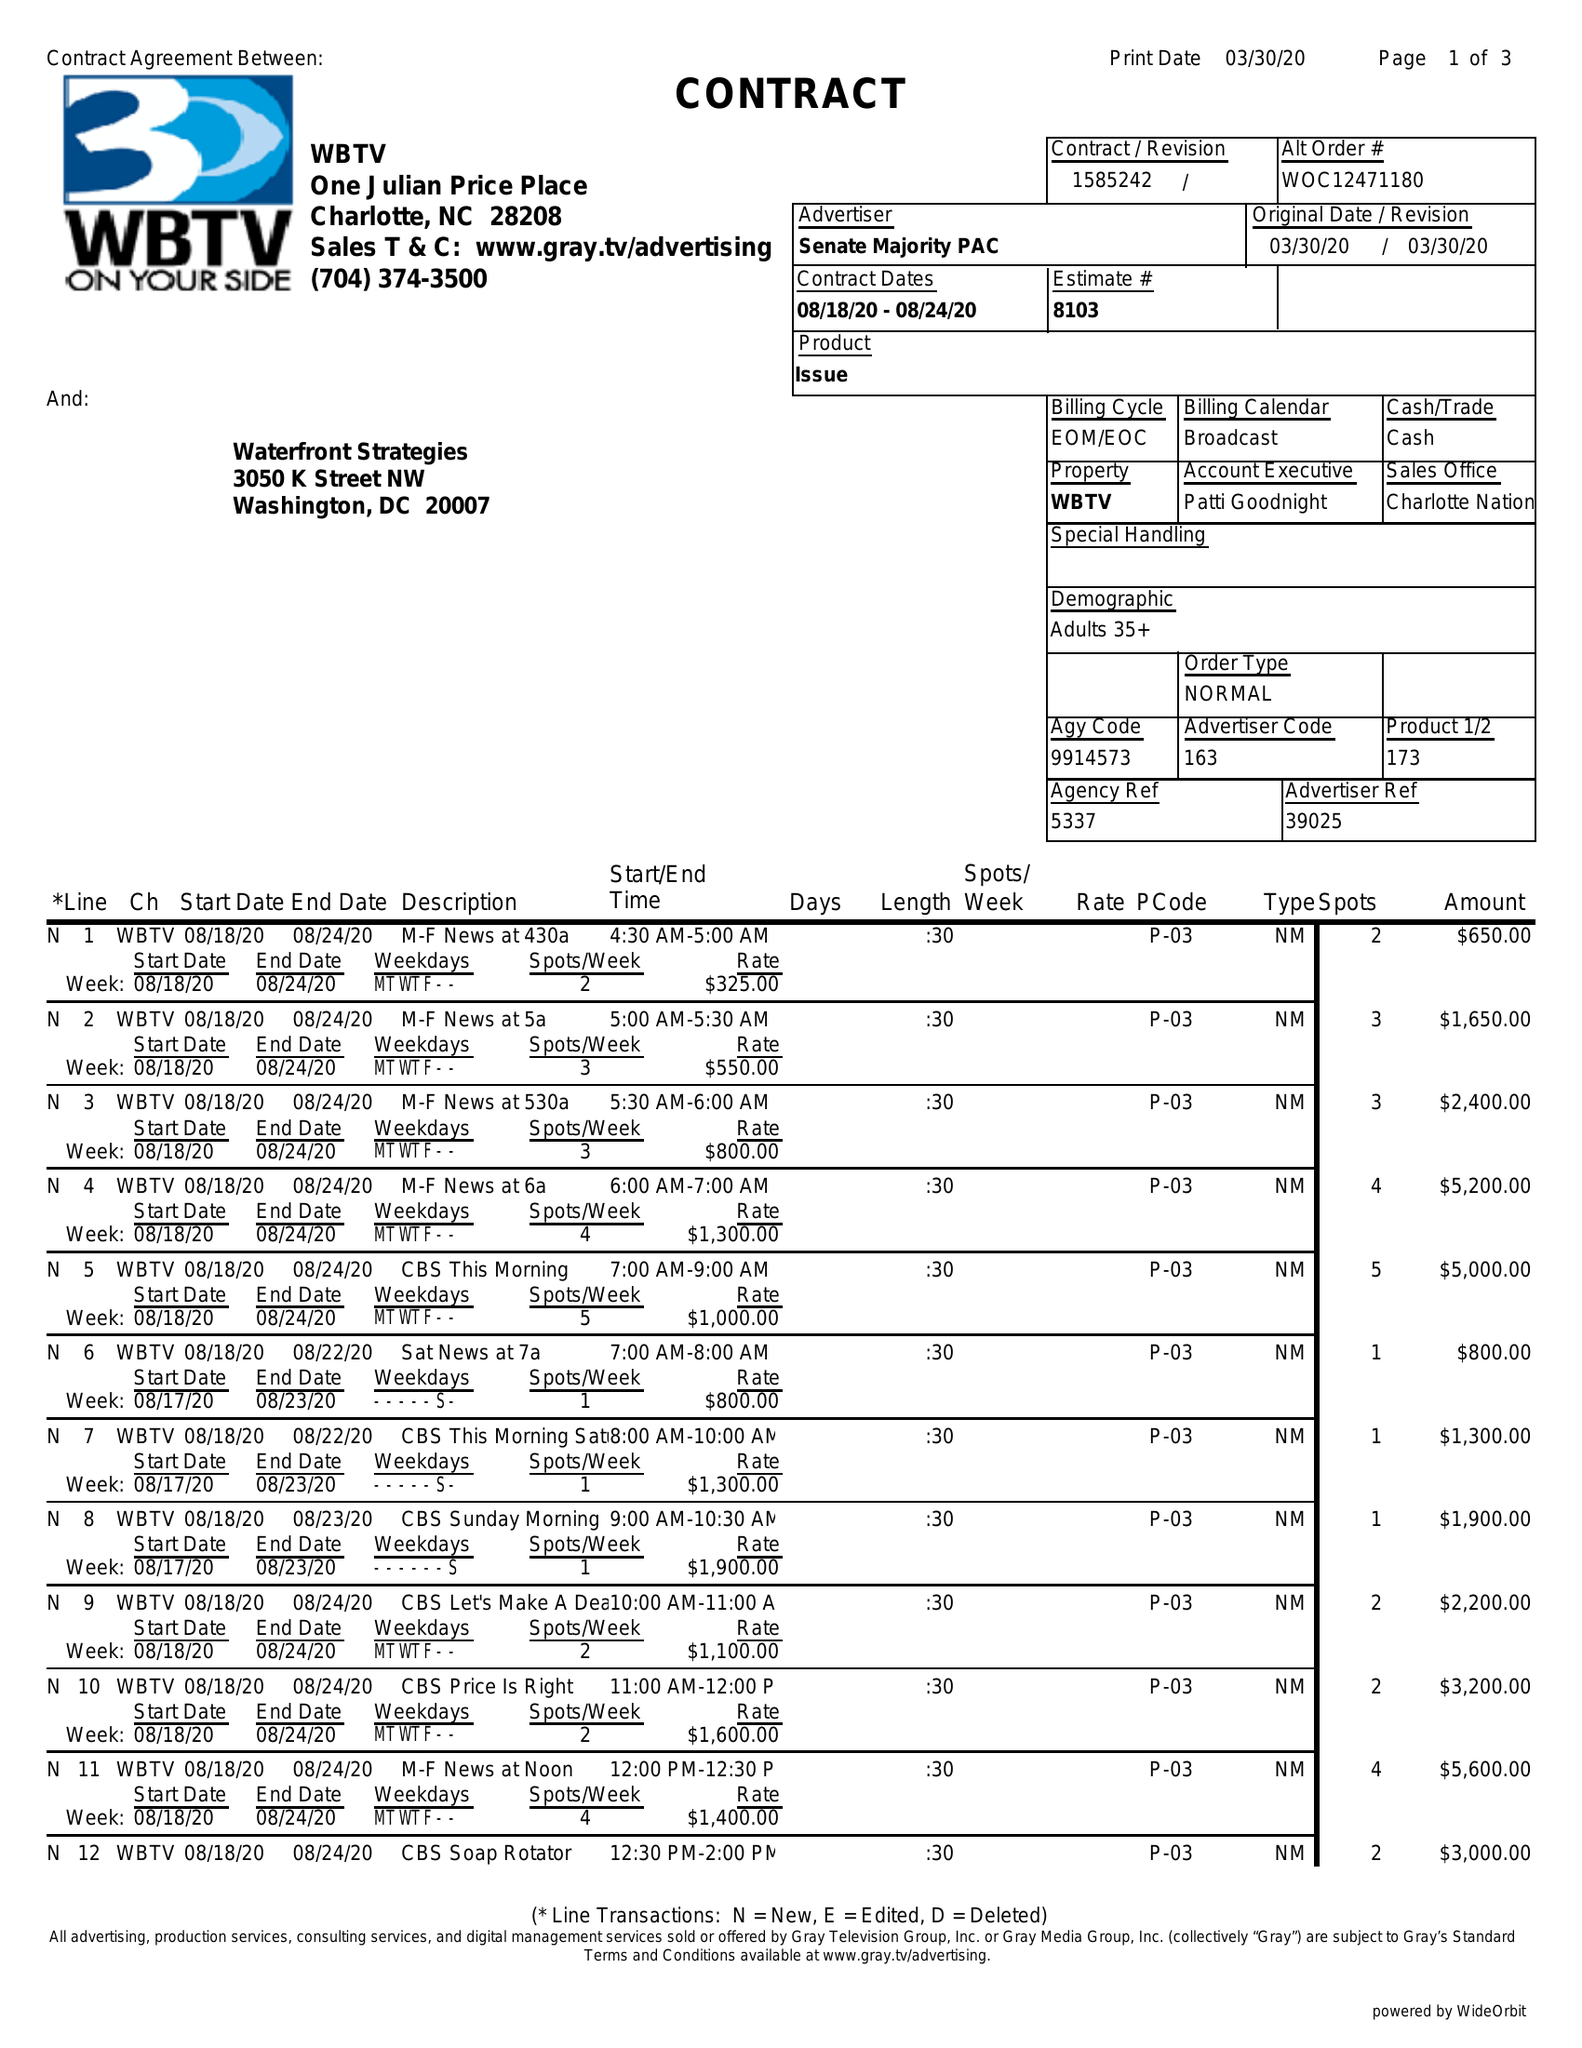What is the value for the flight_from?
Answer the question using a single word or phrase. 08/18/20 